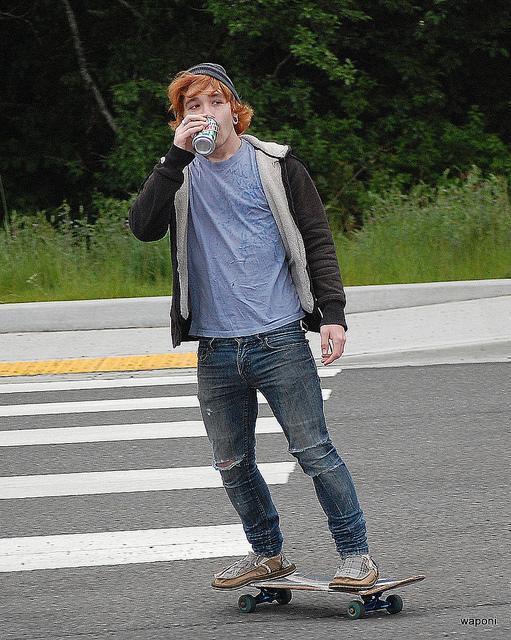How many people are there?
Give a very brief answer. 1. 